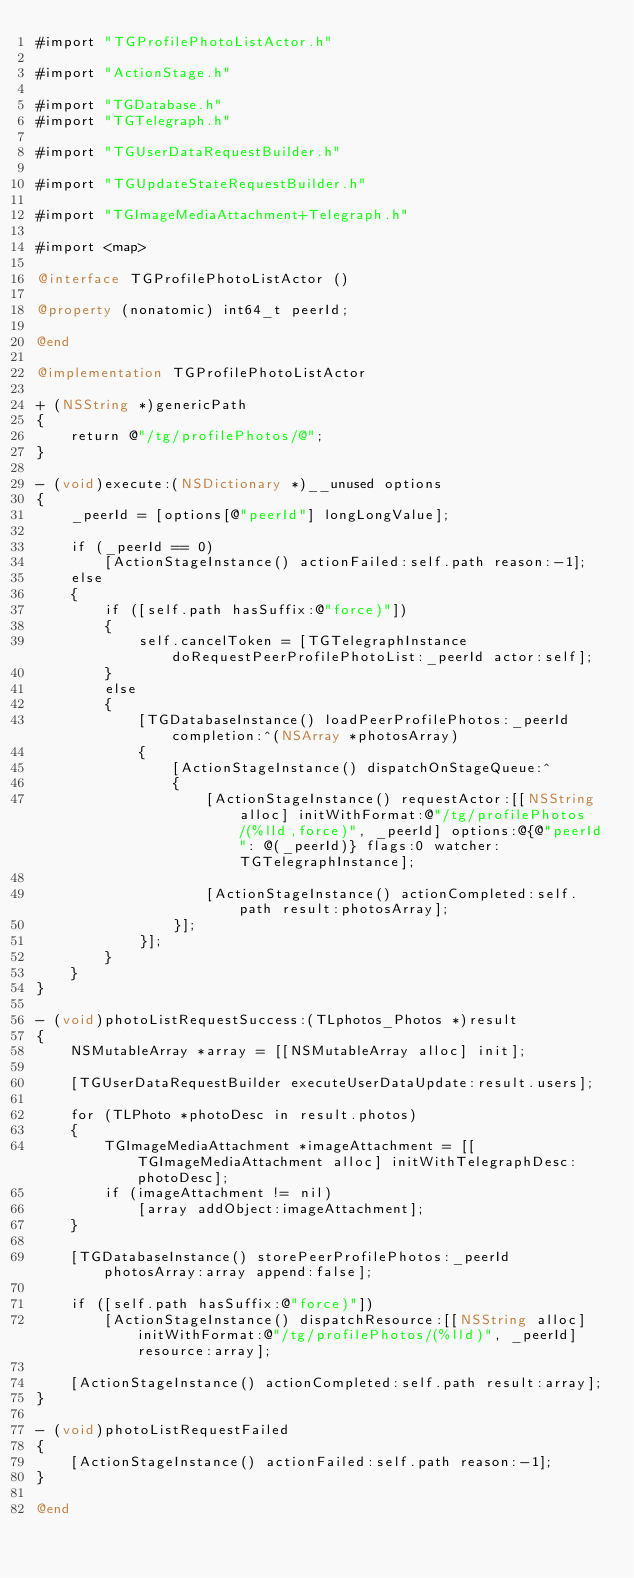Convert code to text. <code><loc_0><loc_0><loc_500><loc_500><_ObjectiveC_>#import "TGProfilePhotoListActor.h"

#import "ActionStage.h"

#import "TGDatabase.h"
#import "TGTelegraph.h"

#import "TGUserDataRequestBuilder.h"

#import "TGUpdateStateRequestBuilder.h"

#import "TGImageMediaAttachment+Telegraph.h"

#import <map>

@interface TGProfilePhotoListActor ()

@property (nonatomic) int64_t peerId;

@end

@implementation TGProfilePhotoListActor

+ (NSString *)genericPath
{
    return @"/tg/profilePhotos/@";
}

- (void)execute:(NSDictionary *)__unused options
{
    _peerId = [options[@"peerId"] longLongValue];
    
    if (_peerId == 0)
        [ActionStageInstance() actionFailed:self.path reason:-1];
    else
    {
        if ([self.path hasSuffix:@"force)"])
        {
            self.cancelToken = [TGTelegraphInstance doRequestPeerProfilePhotoList:_peerId actor:self];
        }
        else
        {
            [TGDatabaseInstance() loadPeerProfilePhotos:_peerId completion:^(NSArray *photosArray)
            {
                [ActionStageInstance() dispatchOnStageQueue:^
                {
                    [ActionStageInstance() requestActor:[[NSString alloc] initWithFormat:@"/tg/profilePhotos/(%lld,force)", _peerId] options:@{@"peerId": @(_peerId)} flags:0 watcher:TGTelegraphInstance];
                    
                    [ActionStageInstance() actionCompleted:self.path result:photosArray];
                }];
            }];
        }
    }
}

- (void)photoListRequestSuccess:(TLphotos_Photos *)result
{
    NSMutableArray *array = [[NSMutableArray alloc] init];
    
    [TGUserDataRequestBuilder executeUserDataUpdate:result.users];
    
    for (TLPhoto *photoDesc in result.photos)
    {
        TGImageMediaAttachment *imageAttachment = [[TGImageMediaAttachment alloc] initWithTelegraphDesc:photoDesc];
        if (imageAttachment != nil)
            [array addObject:imageAttachment];
    }
    
    [TGDatabaseInstance() storePeerProfilePhotos:_peerId photosArray:array append:false];
    
    if ([self.path hasSuffix:@"force)"])
        [ActionStageInstance() dispatchResource:[[NSString alloc] initWithFormat:@"/tg/profilePhotos/(%lld)", _peerId] resource:array];
    
    [ActionStageInstance() actionCompleted:self.path result:array];
}

- (void)photoListRequestFailed
{
    [ActionStageInstance() actionFailed:self.path reason:-1];
}

@end
</code> 